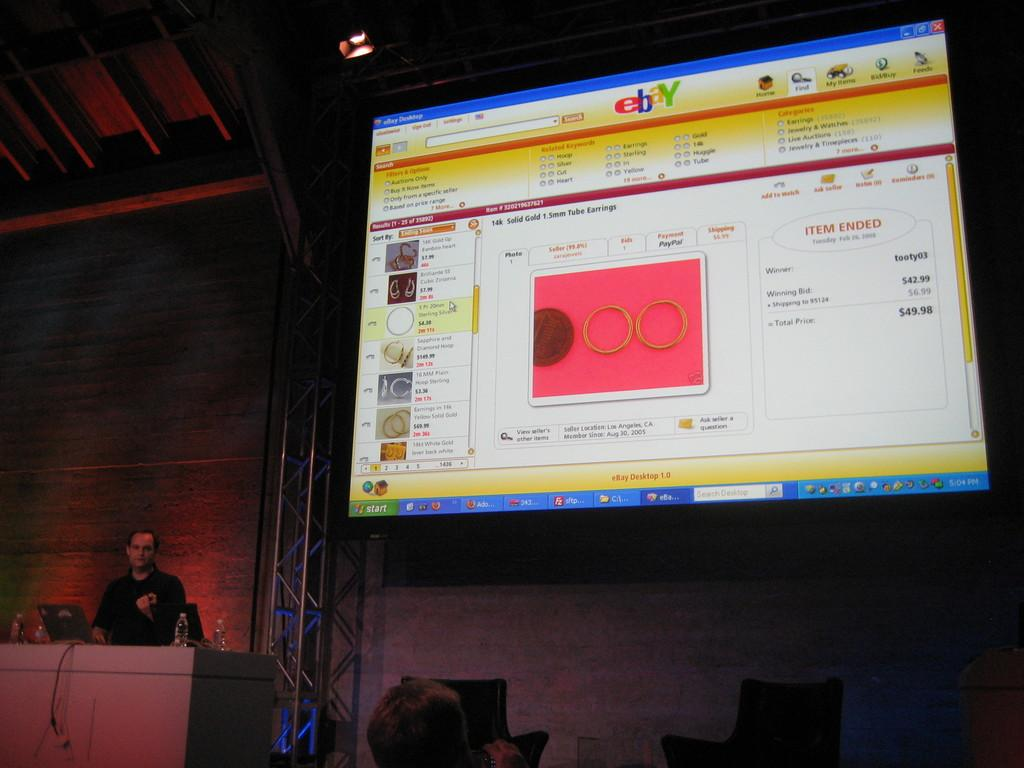Provide a one-sentence caption for the provided image. a computer with the site eBay being displayed. 